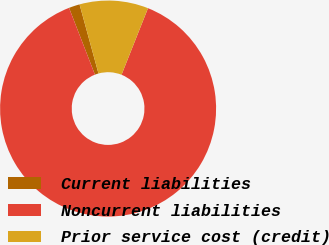<chart> <loc_0><loc_0><loc_500><loc_500><pie_chart><fcel>Current liabilities<fcel>Noncurrent liabilities<fcel>Prior service cost (credit)<nl><fcel>1.63%<fcel>88.09%<fcel>10.28%<nl></chart> 